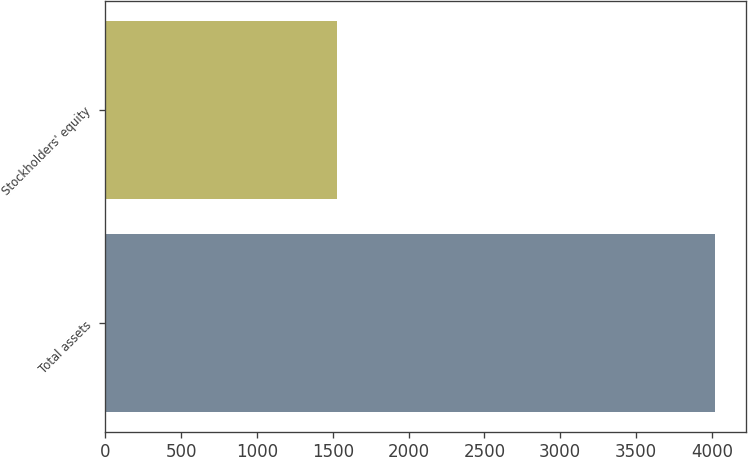Convert chart to OTSL. <chart><loc_0><loc_0><loc_500><loc_500><bar_chart><fcel>Total assets<fcel>Stockholders' equity<nl><fcel>4023<fcel>1528<nl></chart> 